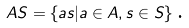Convert formula to latex. <formula><loc_0><loc_0><loc_500><loc_500>A S = \left \{ a s | a \in A , s \in S \right \} \text {.}</formula> 